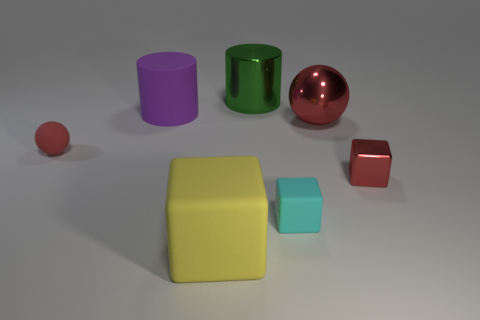Subtract all small rubber blocks. How many blocks are left? 2 Add 2 metallic cubes. How many objects exist? 9 Subtract all yellow blocks. How many blocks are left? 2 Subtract 0 cyan balls. How many objects are left? 7 Subtract all cubes. How many objects are left? 4 Subtract 3 blocks. How many blocks are left? 0 Subtract all green spheres. Subtract all purple cylinders. How many spheres are left? 2 Subtract all large gray matte cubes. Subtract all green shiny things. How many objects are left? 6 Add 1 big red spheres. How many big red spheres are left? 2 Add 7 tiny objects. How many tiny objects exist? 10 